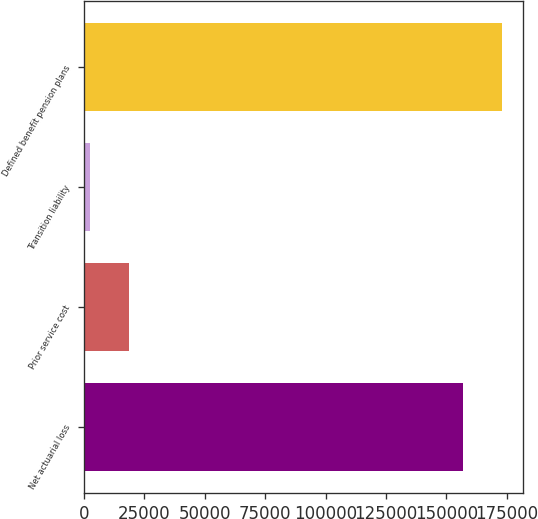Convert chart to OTSL. <chart><loc_0><loc_0><loc_500><loc_500><bar_chart><fcel>Net actuarial loss<fcel>Prior service cost<fcel>Transition liability<fcel>Defined benefit pension plans<nl><fcel>156762<fcel>18778.5<fcel>2690<fcel>172850<nl></chart> 